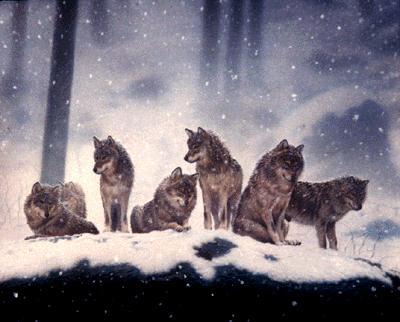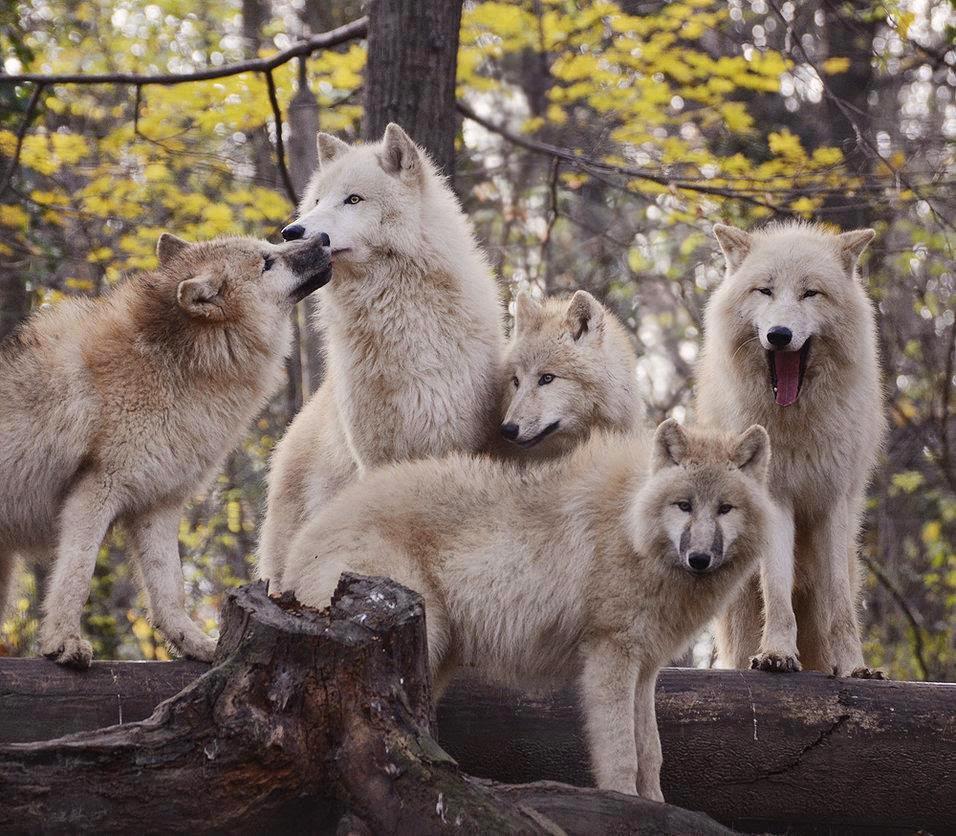The first image is the image on the left, the second image is the image on the right. Considering the images on both sides, is "The image on the left contains at least five wolves that are howling." valid? Answer yes or no. No. The first image is the image on the left, the second image is the image on the right. Evaluate the accuracy of this statement regarding the images: "There are some wolves with white necks that have their heads titled up and are howling.". Is it true? Answer yes or no. No. 